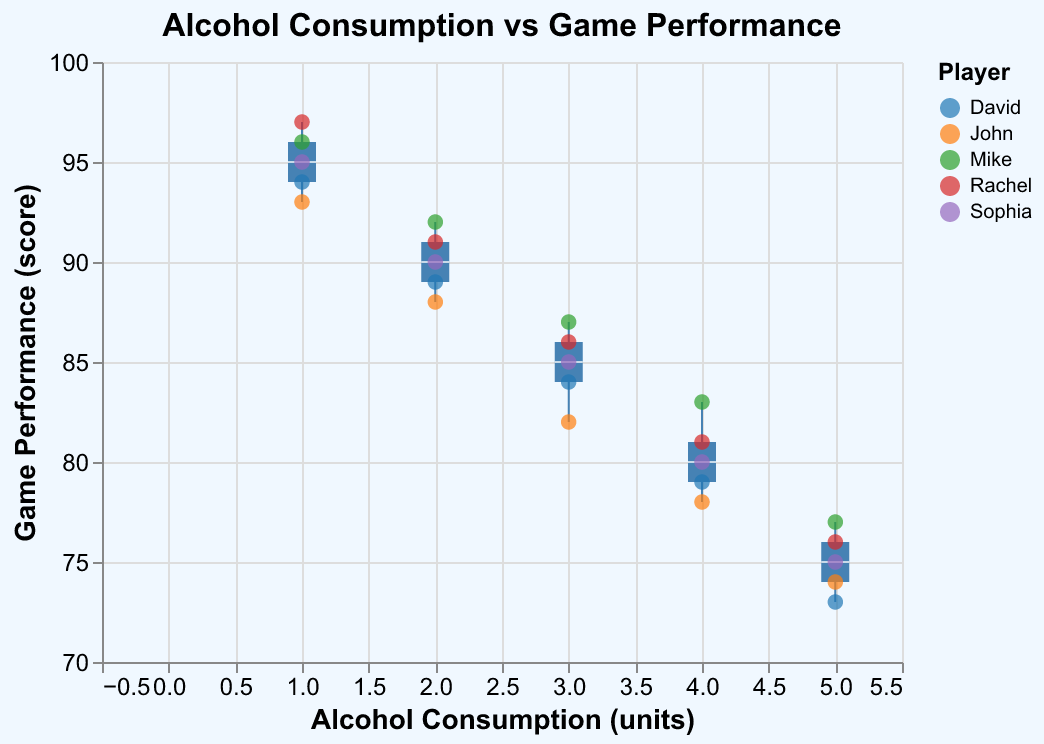How many players' data points are illustrated in the figure? We have data for five players: John, Sophia, Mike, Rachel, and David. Each player has five data points for varying levels of alcohol consumption.
Answer: 5 What is the title of the figure? The title of the figure is located at the top and reads: "Alcohol Consumption vs Game Performance".
Answer: Alcohol Consumption vs Game Performance What do the X and Y axes represent in the figure? The X-axis represents "Alcohol Consumption (units)" and the Y-axis represents "Game Performance (score)".
Answer: Alcohol Consumption (units) and Game Performance (score) Which player had the highest game performance and at what alcohol consumption level? Rachel had the highest game performance with a score of 97 at an alcohol consumption level of 1 unit.
Answer: Rachel at 1 unit What is the median game performance for an alcohol consumption of 2 units? To find the median game performance, observe the box plot for alcohol consumption of 2 units. Since each player has a data point for this level, the median value is found in the middle of the distribution within the box.
Answer: 89 Compare the range of game performance scores between 1 and 5 units of alcohol consumption. For 1 unit of alcohol, the game performance scores range from 93 to 97. For 5 units, they range from 73 to 77. The range for 1 unit is higher compared to 5 units.
Answer: Range at 1 unit is 93-97, range at 5 units is 73-77 Which player shows the most consistent game performance across different levels of alcohol consumption? Consistency suggests smaller deviations in performance. Looking at scatter points for each player: John, Sophia, Mike, Rachel, and David, Rachel consistently performs well with less fluctuation.
Answer: Rachel Does higher alcohol consumption correlate with better or worse game performance? Reviewing the overall trends in scatter points and box plots, higher alcohol consumption (e.g., 5 units) generally correlates with worse game performance compared to lower levels (e.g., 1 unit).
Answer: Worse performance What's the average game performance for Sophia? Sophia's game performance scores are 90, 95, 85, 80, and 75. Adding these and dividing by 5 gives (90+95+85+80+75)/5 = 425/5.
Answer: 85 